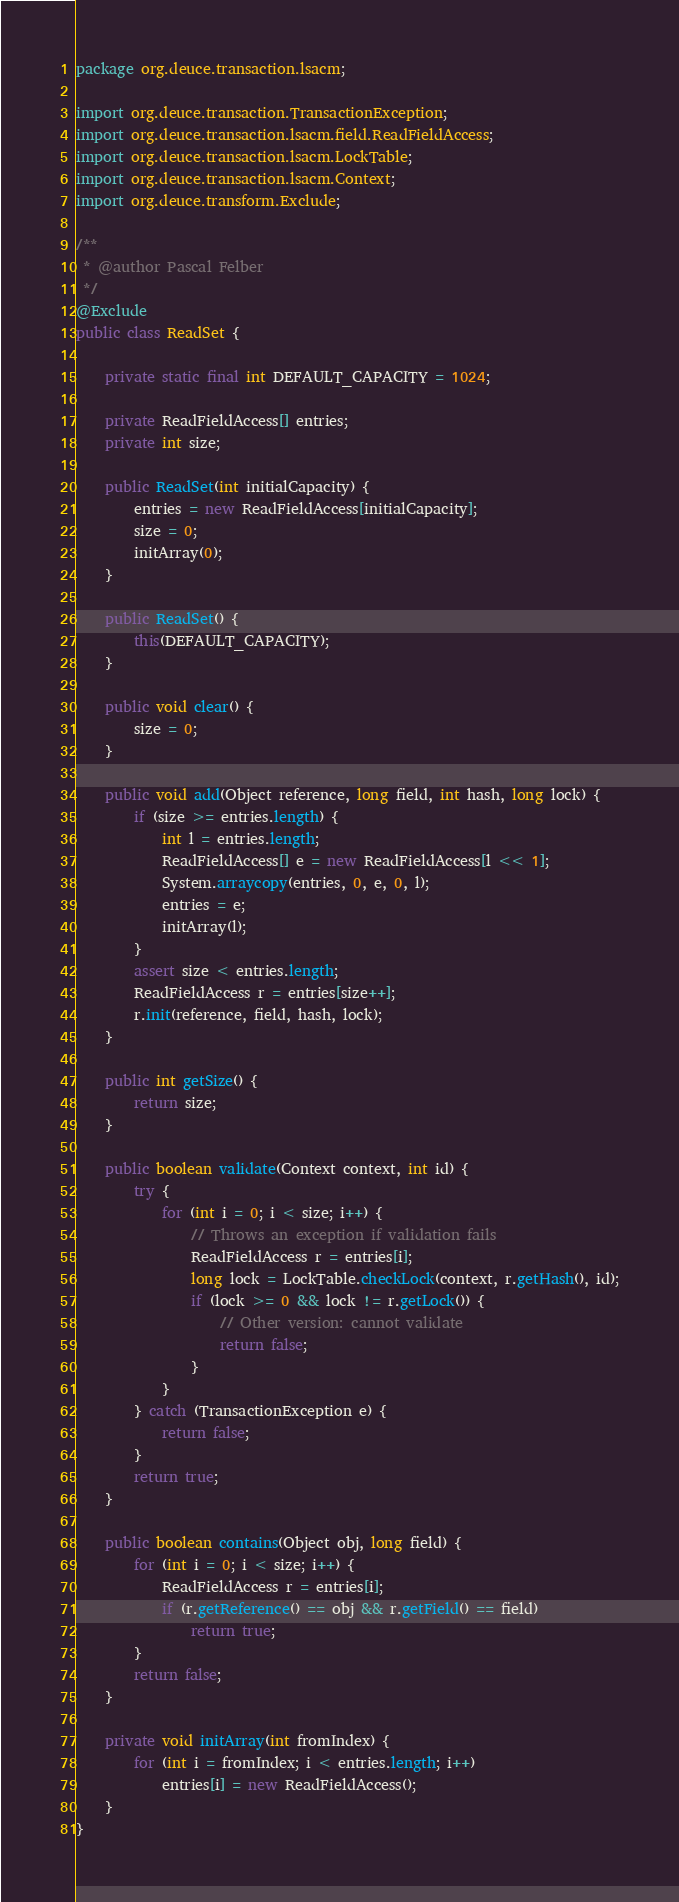Convert code to text. <code><loc_0><loc_0><loc_500><loc_500><_Java_>package org.deuce.transaction.lsacm;

import org.deuce.transaction.TransactionException;
import org.deuce.transaction.lsacm.field.ReadFieldAccess;
import org.deuce.transaction.lsacm.LockTable;
import org.deuce.transaction.lsacm.Context;
import org.deuce.transform.Exclude;

/**
 * @author Pascal Felber
 */
@Exclude
public class ReadSet {

	private static final int DEFAULT_CAPACITY = 1024;

	private ReadFieldAccess[] entries;
	private int size;

	public ReadSet(int initialCapacity) {
		entries = new ReadFieldAccess[initialCapacity];
		size = 0;
		initArray(0);
	}

	public ReadSet() {
		this(DEFAULT_CAPACITY);
	}

	public void clear() {
		size = 0;
	}

	public void add(Object reference, long field, int hash, long lock) {
		if (size >= entries.length) {
			int l = entries.length;
			ReadFieldAccess[] e = new ReadFieldAccess[l << 1];
			System.arraycopy(entries, 0, e, 0, l);
			entries = e;
			initArray(l);
		}
		assert size < entries.length;
		ReadFieldAccess r = entries[size++];
		r.init(reference, field, hash, lock);
	}

	public int getSize() {
		return size;
	}

	public boolean validate(Context context, int id) {
		try {
			for (int i = 0; i < size; i++) {
				// Throws an exception if validation fails
				ReadFieldAccess r = entries[i];
				long lock = LockTable.checkLock(context, r.getHash(), id);
				if (lock >= 0 && lock != r.getLock()) {
					// Other version: cannot validate
					return false;
				}
			}
		} catch (TransactionException e) {
			return false;
		}
		return true;
	}

	public boolean contains(Object obj, long field) {
		for (int i = 0; i < size; i++) {
			ReadFieldAccess r = entries[i];
			if (r.getReference() == obj && r.getField() == field)
				return true;
		}
		return false;
	}

	private void initArray(int fromIndex) {
		for (int i = fromIndex; i < entries.length; i++)
			entries[i] = new ReadFieldAccess();
	}
}
</code> 